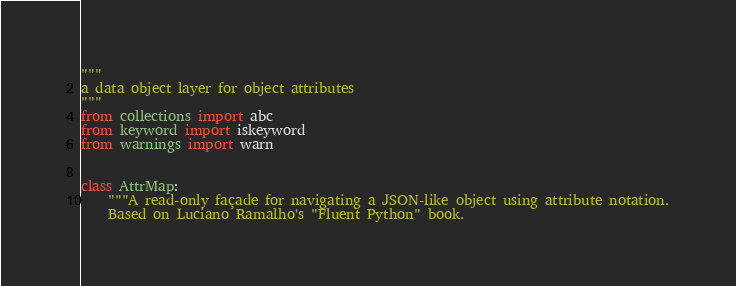<code> <loc_0><loc_0><loc_500><loc_500><_Python_>"""
a data object layer for object attributes
"""
from collections import abc
from keyword import iskeyword
from warnings import warn


class AttrMap:
    """A read-only façade for navigating a JSON-like object using attribute notation.
    Based on Luciano Ramalho's "Fluent Python" book.
</code> 